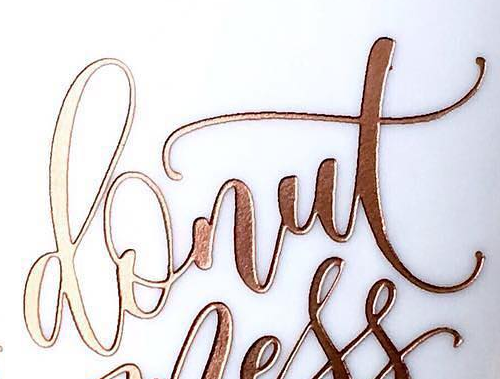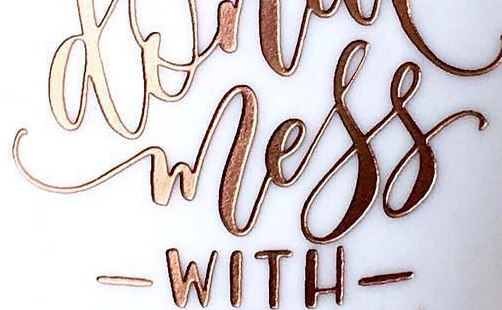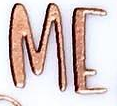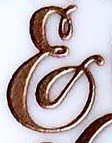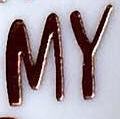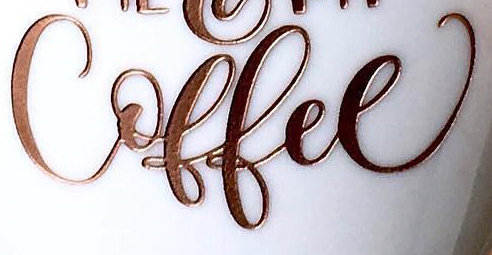Transcribe the words shown in these images in order, separated by a semicolon. donut; wless; ME; &; MY; Coffee 